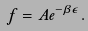<formula> <loc_0><loc_0><loc_500><loc_500>f = A e ^ { - \beta \epsilon } .</formula> 